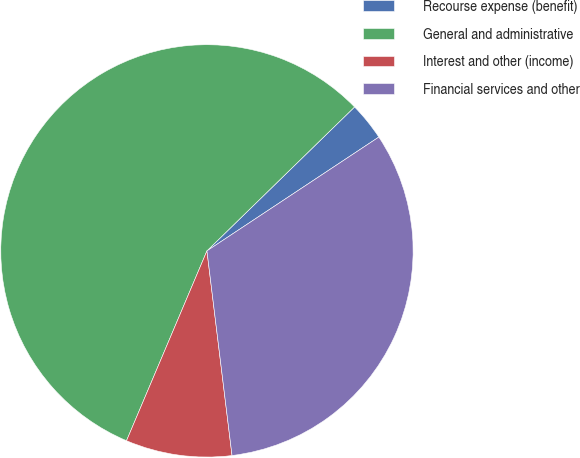<chart> <loc_0><loc_0><loc_500><loc_500><pie_chart><fcel>Recourse expense (benefit)<fcel>General and administrative<fcel>Interest and other (income)<fcel>Financial services and other<nl><fcel>2.99%<fcel>56.33%<fcel>8.32%<fcel>32.37%<nl></chart> 